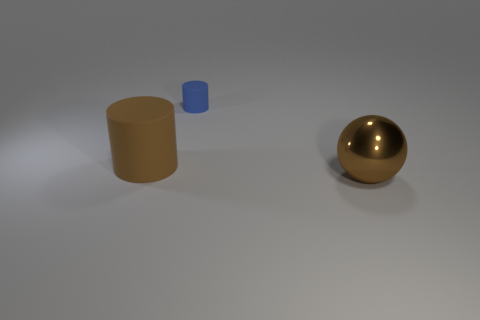Add 3 tiny blue objects. How many objects exist? 6 Subtract all blue cylinders. How many cylinders are left? 1 Subtract 1 spheres. How many spheres are left? 0 Subtract 0 cyan cubes. How many objects are left? 3 Subtract all cylinders. How many objects are left? 1 Subtract all blue cylinders. Subtract all gray balls. How many cylinders are left? 1 Subtract all purple cubes. How many blue cylinders are left? 1 Subtract all large gray shiny objects. Subtract all tiny blue cylinders. How many objects are left? 2 Add 3 small things. How many small things are left? 4 Add 3 tiny red spheres. How many tiny red spheres exist? 3 